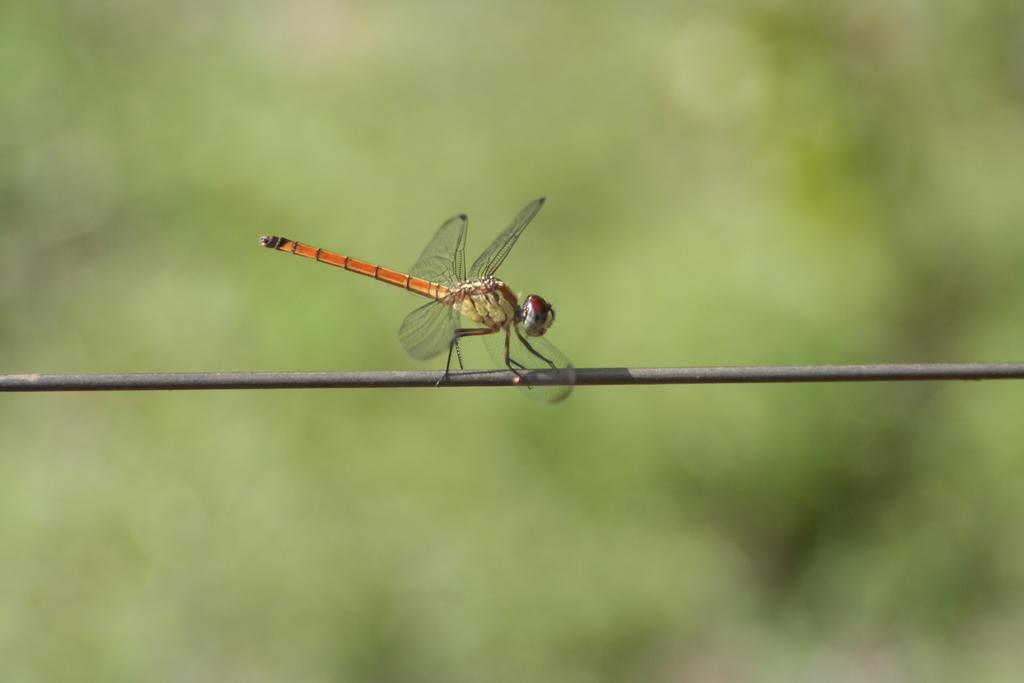What is present in the image? There is an insect in the image. Where is the insect located? The insect is on a wire. Can you describe the background of the image? The background of the image is blurry. What type of fruit is the insect holding in the image? There is no fruit present in the image, and the insect is not holding anything. 